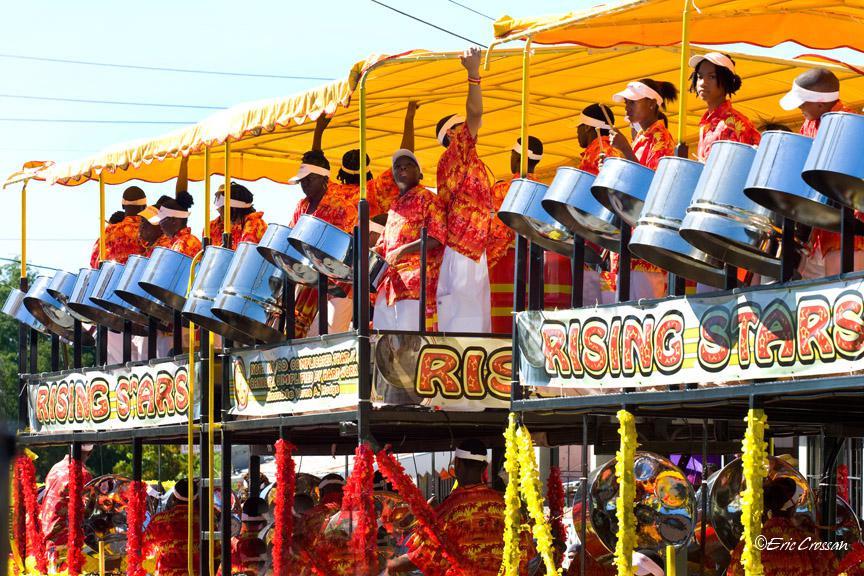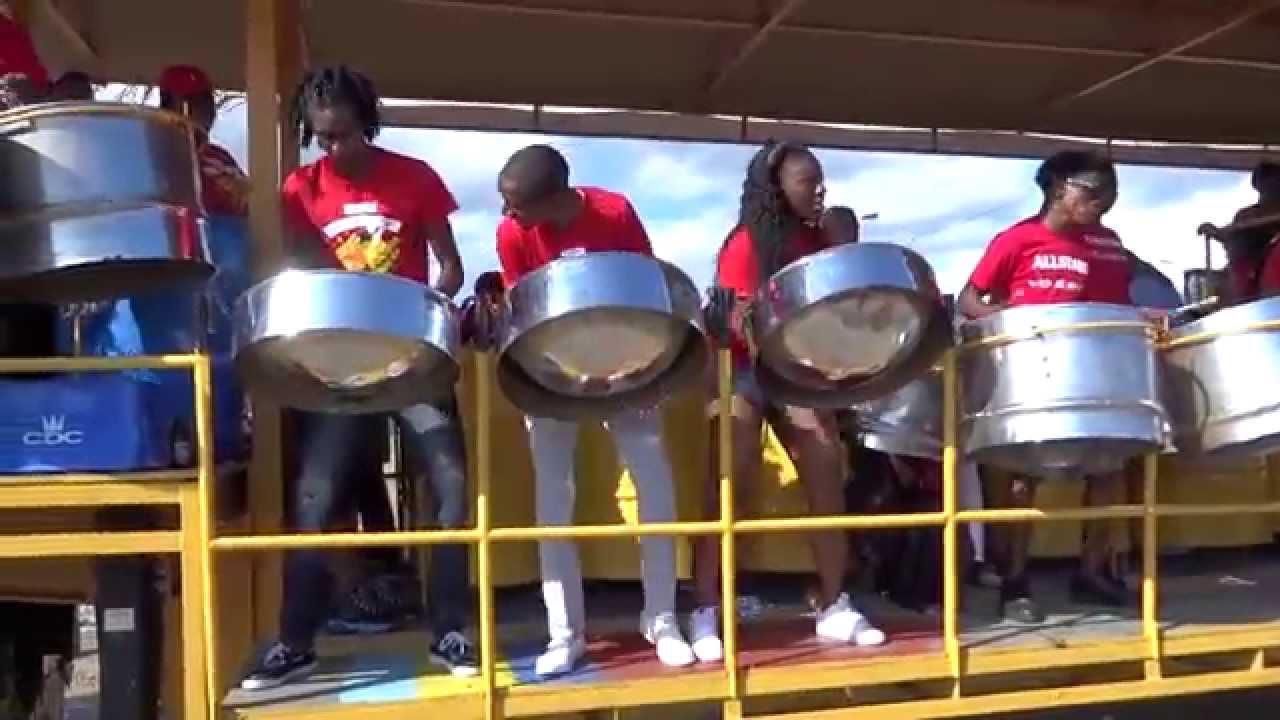The first image is the image on the left, the second image is the image on the right. Analyze the images presented: Is the assertion "The foreground of one image features a row of at least three forward-turned people in red shirts bending over silver drums." valid? Answer yes or no. Yes. The first image is the image on the left, the second image is the image on the right. For the images shown, is this caption "In the image to the right, people wearing white shirts are banging steel drum instruments." true? Answer yes or no. No. 